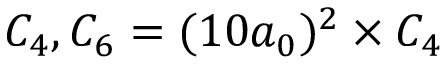Convert formula to latex. <formula><loc_0><loc_0><loc_500><loc_500>C _ { 4 } , C _ { 6 } = ( 1 0 a _ { 0 } ) ^ { 2 } \times C _ { 4 }</formula> 